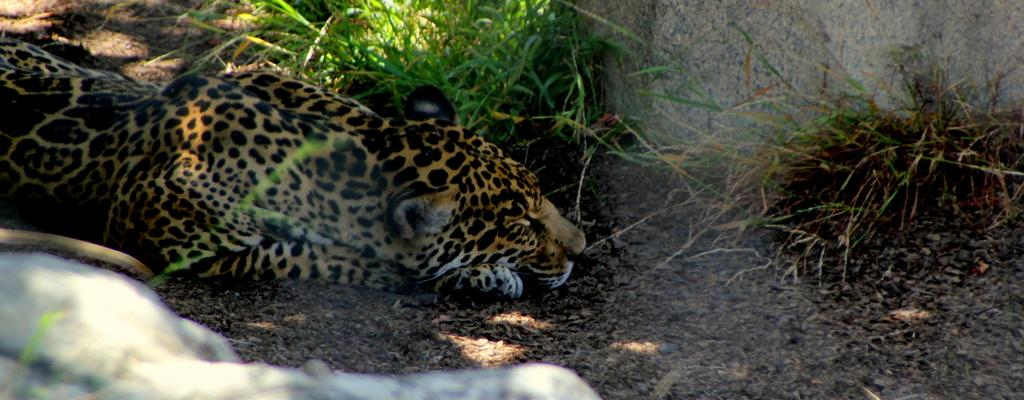What animal is present in the image? There is a tiger in the image. What is the tiger's position in the image? The tiger is lying on the ground. What type of terrain can be seen in the background of the image? There are rocks and grass in the background of the image. What type of shoe is the tiger wearing in the image? There is no shoe present in the image, as tigers do not wear shoes. 